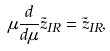Convert formula to latex. <formula><loc_0><loc_0><loc_500><loc_500>\mu \frac { d } { d \mu } \tilde { z } _ { I R } = \tilde { z } _ { I R } ,</formula> 